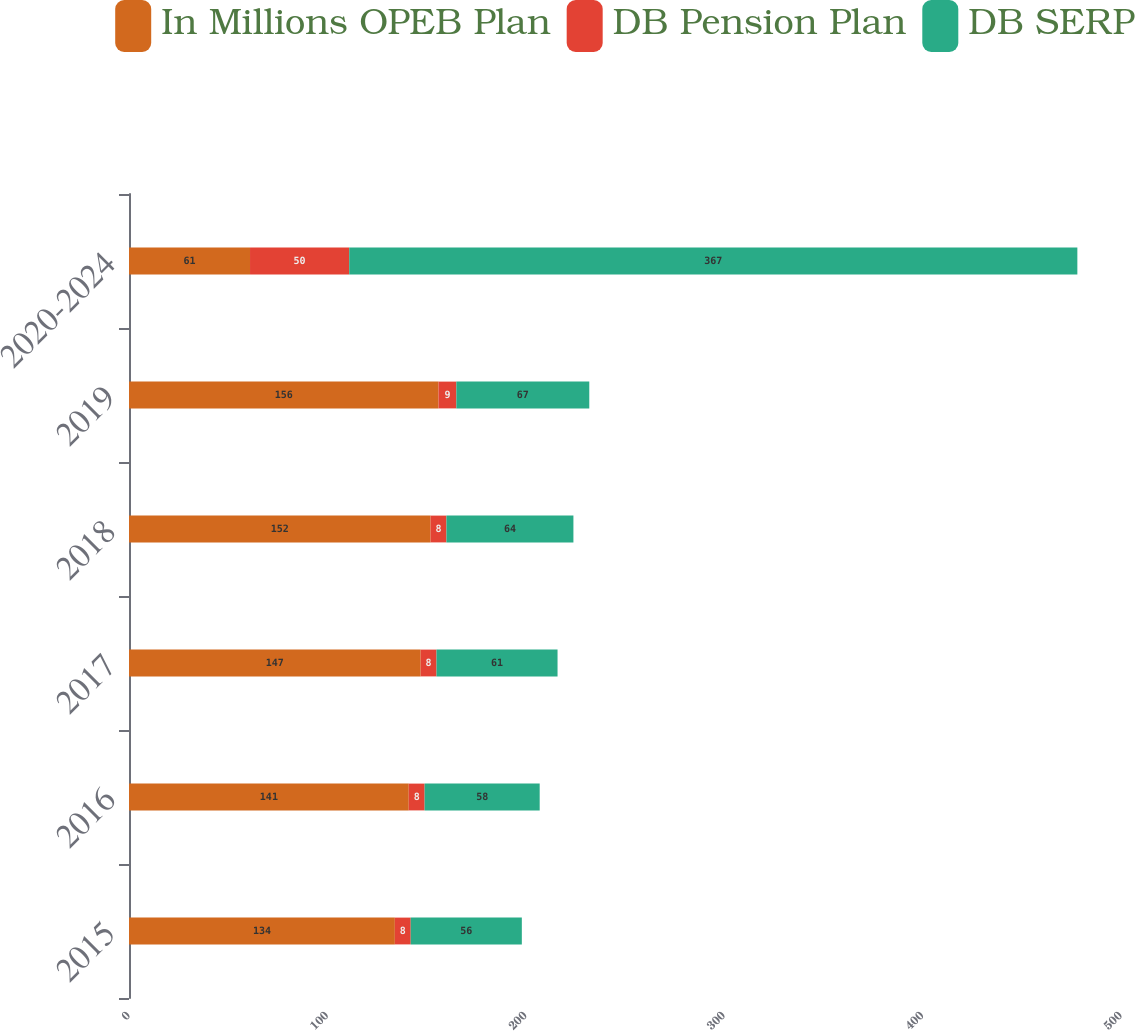<chart> <loc_0><loc_0><loc_500><loc_500><stacked_bar_chart><ecel><fcel>2015<fcel>2016<fcel>2017<fcel>2018<fcel>2019<fcel>2020-2024<nl><fcel>In Millions OPEB Plan<fcel>134<fcel>141<fcel>147<fcel>152<fcel>156<fcel>61<nl><fcel>DB Pension Plan<fcel>8<fcel>8<fcel>8<fcel>8<fcel>9<fcel>50<nl><fcel>DB SERP<fcel>56<fcel>58<fcel>61<fcel>64<fcel>67<fcel>367<nl></chart> 